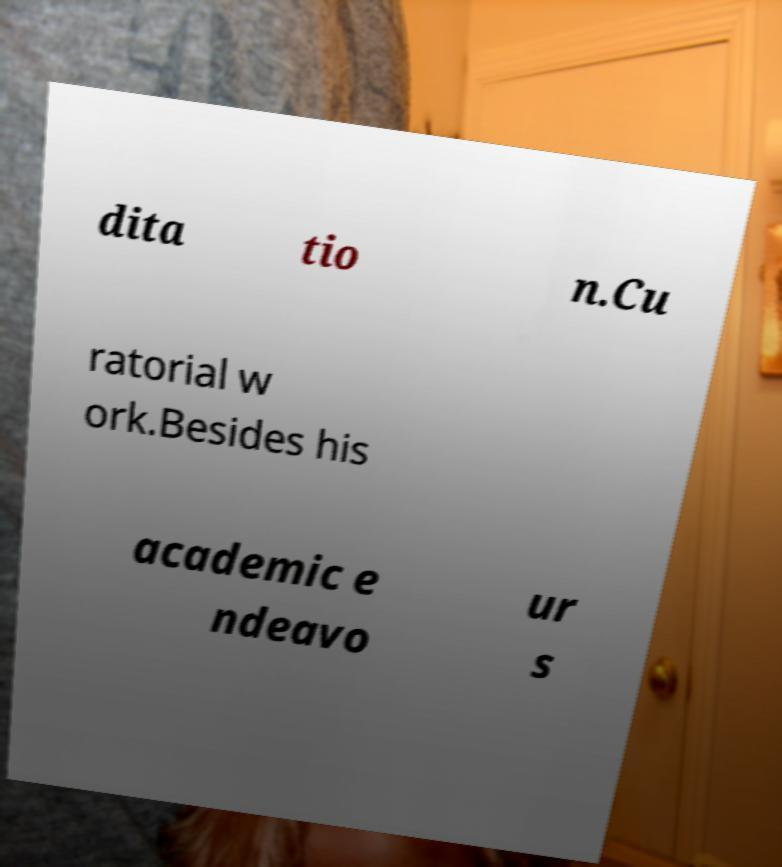Could you extract and type out the text from this image? dita tio n.Cu ratorial w ork.Besides his academic e ndeavo ur s 